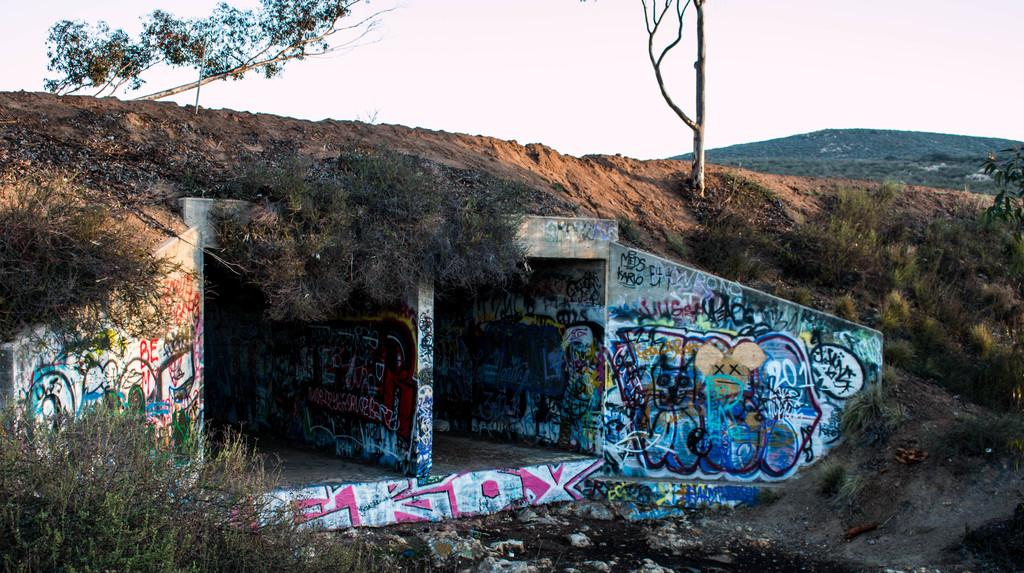<image>
Render a clear and concise summary of the photo. graffiti on the sides of a small building that says 'eroy 